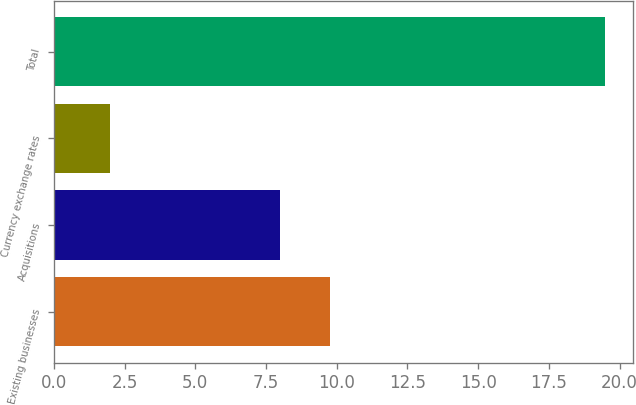Convert chart to OTSL. <chart><loc_0><loc_0><loc_500><loc_500><bar_chart><fcel>Existing businesses<fcel>Acquisitions<fcel>Currency exchange rates<fcel>Total<nl><fcel>9.75<fcel>8<fcel>2<fcel>19.5<nl></chart> 